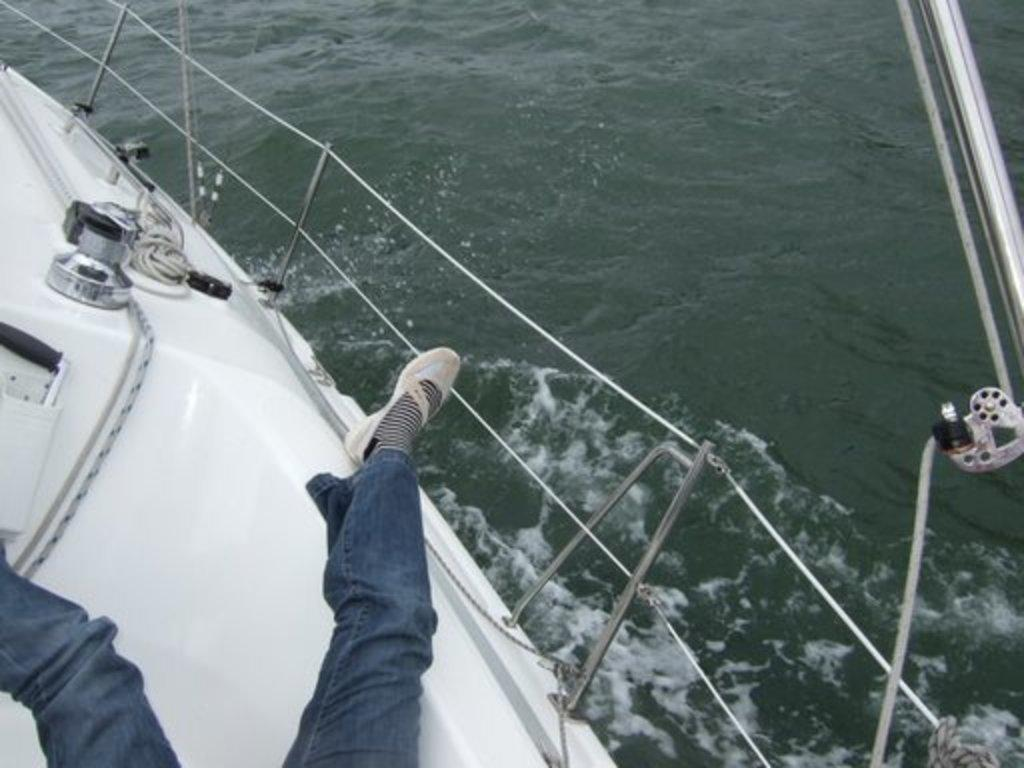What is the main subject of the image? The main subject of the image is a boat. Where is the boat located? The boat is on the water. What are the ropes and rods used for in the image? The ropes and rods are likely used for fishing or anchoring the boat. Can you describe the person in the image? The legs of a person are present in the image, but their upper body is not visible. Who is the creator of the fight scene depicted in the image? There is no fight scene present in the image; it features a boat on the water with ropes, rods, and a person's legs. 